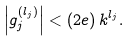<formula> <loc_0><loc_0><loc_500><loc_500>\left | g _ { j } ^ { ( l _ { j } ) } \right | < ( 2 e ) \, k ^ { l _ { j } } .</formula> 